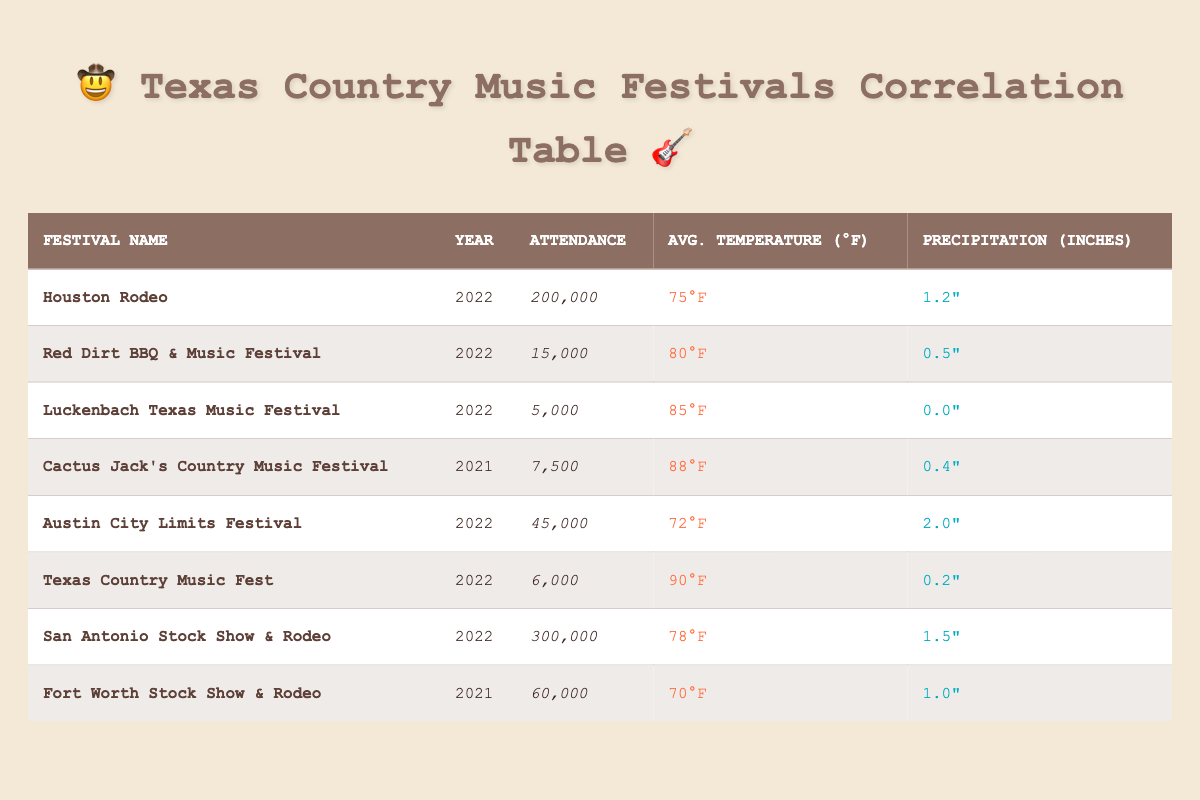What is the attendance at the Houston Rodeo in 2022? The table shows that the Houston Rodeo had an attendance of 200,000 in 2022.
Answer: 200,000 Which festival had the highest attendance? By comparing the attendance figures for each festival, the San Antonio Stock Show & Rodeo with an attendance of 300,000 has the highest number.
Answer: San Antonio Stock Show & Rodeo What is the average temperature of the festivals listed in 2022? Adding the average temperatures for the festivals in 2022 (75, 80, 85, 72, 90, 78) gives a total of 480. Since there are six festivals, the average temperature is 480/6 = 80°F.
Answer: 80°F Did the Luckenbach Texas Music Festival have any precipitation? The table indicates that the Luckenbach Texas Music Festival had 0.0 inches of precipitation, so it did not have any.
Answer: No What is the total attendance of the festivals in 2022? Adding up the attendances for the festivals in 2022 (200,000 + 15,000 + 5,000 + 45,000 + 6,000 + 300,000) gives a total attendance of 571,000.
Answer: 571,000 How many inches of precipitation did the Austin City Limits Festival have? According to the table, the Austin City Limits Festival had 2.0 inches of precipitation.
Answer: 2.0 inches Is the average temperature related to higher attendance? A general observation of the data suggests that higher average temperatures (like for Texas Country Music Fest at 90°F) did not lead to higher attendance, as lower temperature festivals like Houston Rodeo at 75°F had more attendees.
Answer: No What is the difference in attendance between the highest and lowest festival? The highest attendance is 300,000 (San Antonio Stock Show & Rodeo) and the lowest is 5,000 (Luckenbach Texas Music Festival). The difference is 300,000 - 5,000 = 295,000.
Answer: 295,000 